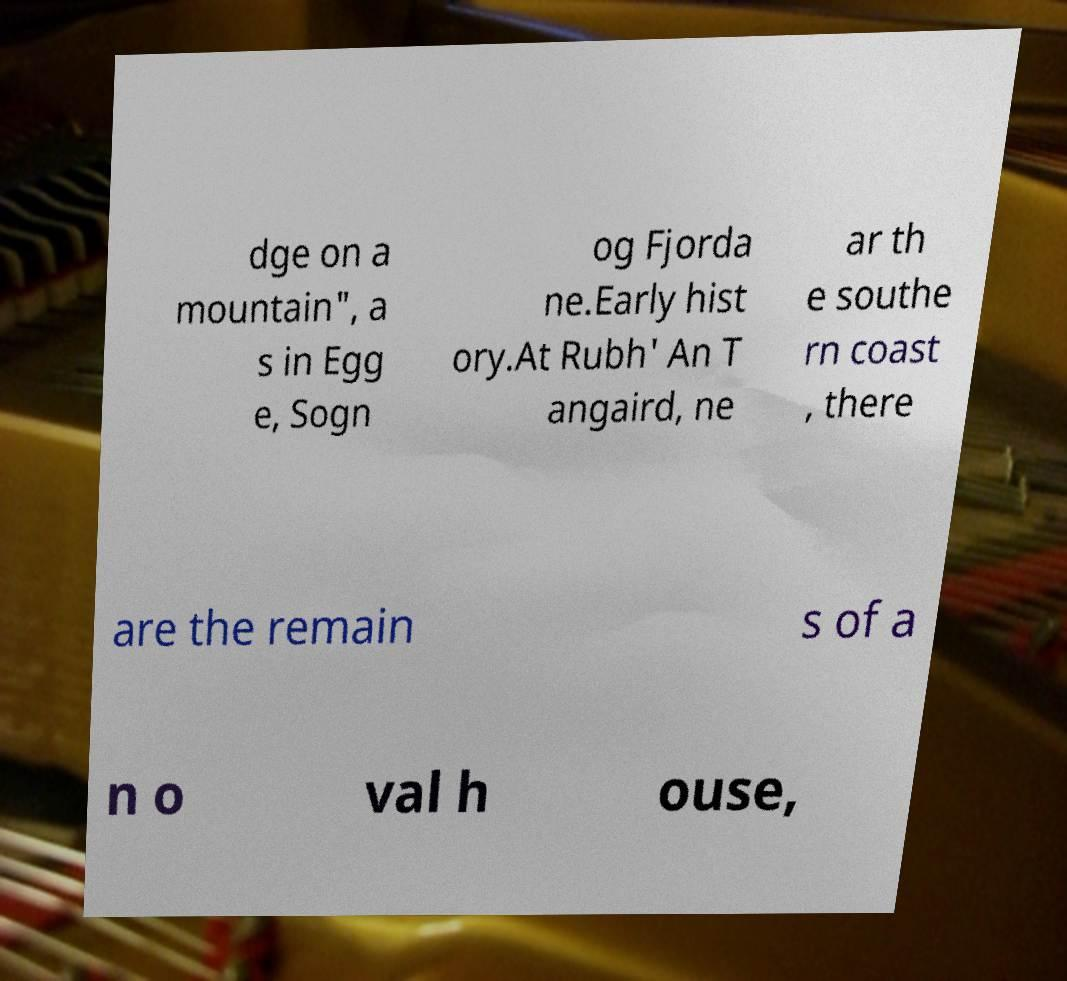Please identify and transcribe the text found in this image. dge on a mountain", a s in Egg e, Sogn og Fjorda ne.Early hist ory.At Rubh' An T angaird, ne ar th e southe rn coast , there are the remain s of a n o val h ouse, 